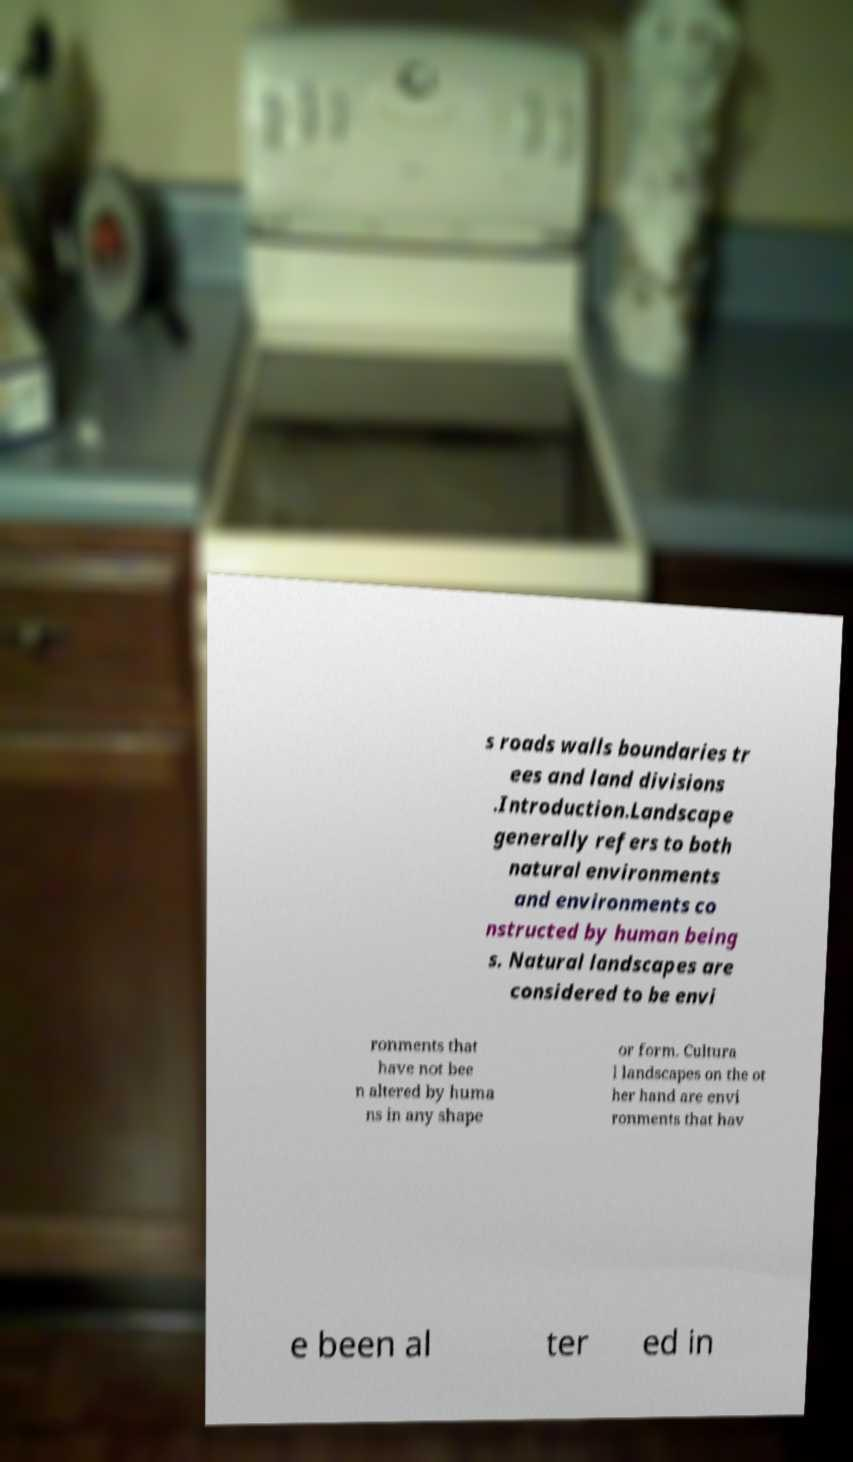What messages or text are displayed in this image? I need them in a readable, typed format. s roads walls boundaries tr ees and land divisions .Introduction.Landscape generally refers to both natural environments and environments co nstructed by human being s. Natural landscapes are considered to be envi ronments that have not bee n altered by huma ns in any shape or form. Cultura l landscapes on the ot her hand are envi ronments that hav e been al ter ed in 